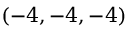Convert formula to latex. <formula><loc_0><loc_0><loc_500><loc_500>( - 4 , - 4 , - 4 )</formula> 